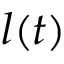Convert formula to latex. <formula><loc_0><loc_0><loc_500><loc_500>l ( t )</formula> 